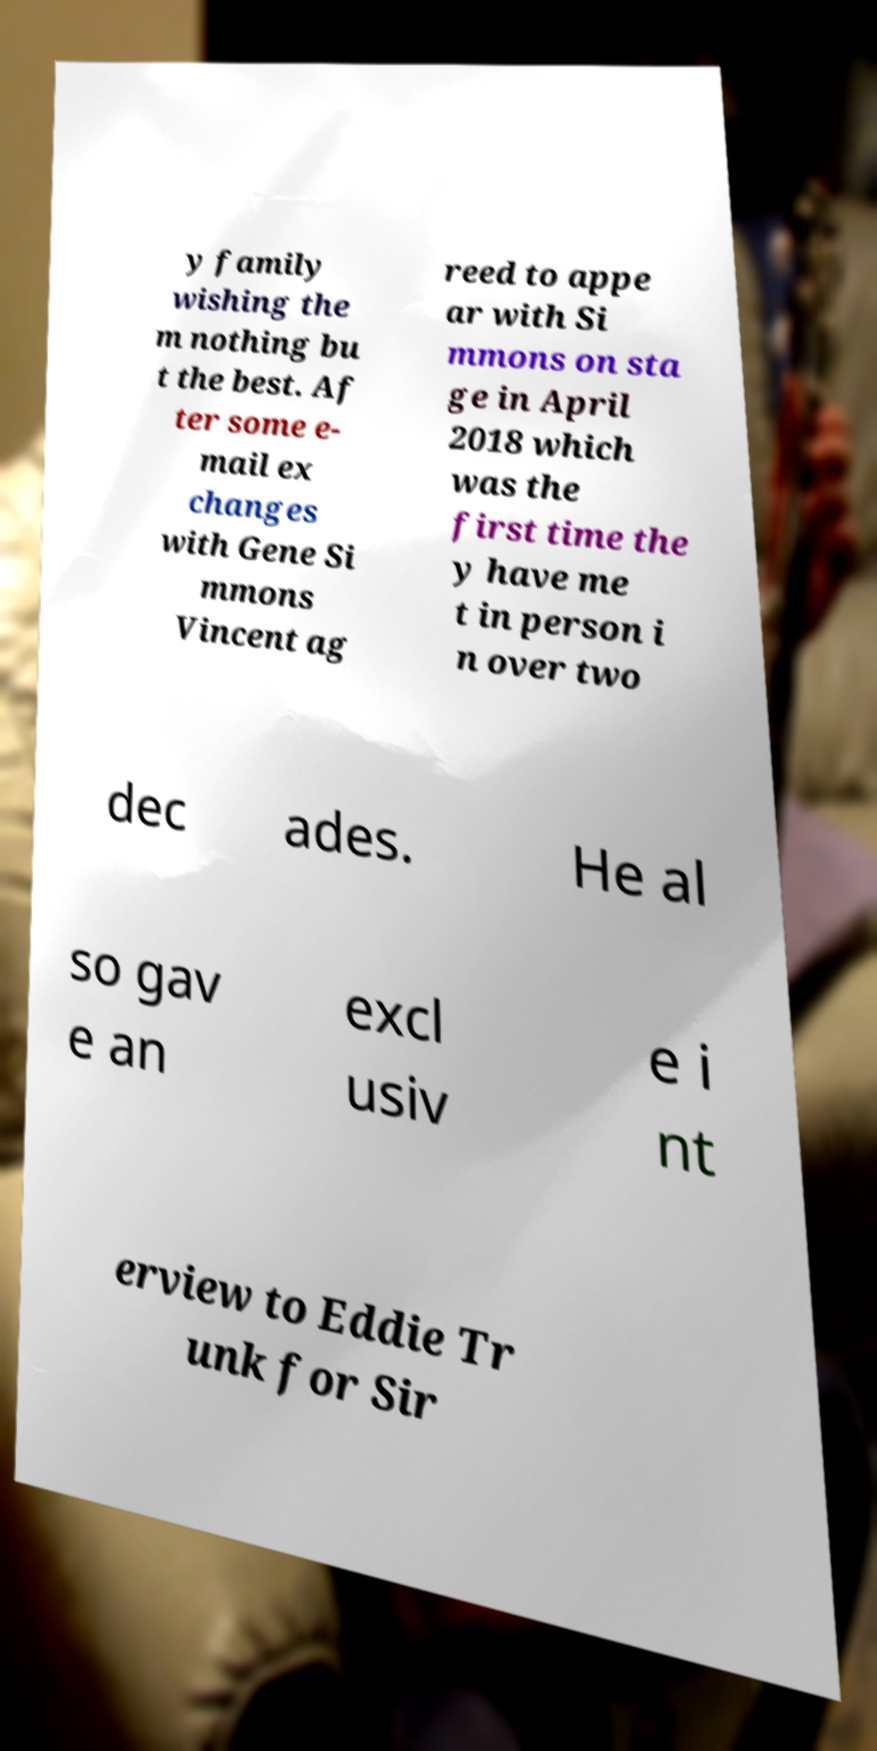Please read and relay the text visible in this image. What does it say? y family wishing the m nothing bu t the best. Af ter some e- mail ex changes with Gene Si mmons Vincent ag reed to appe ar with Si mmons on sta ge in April 2018 which was the first time the y have me t in person i n over two dec ades. He al so gav e an excl usiv e i nt erview to Eddie Tr unk for Sir 